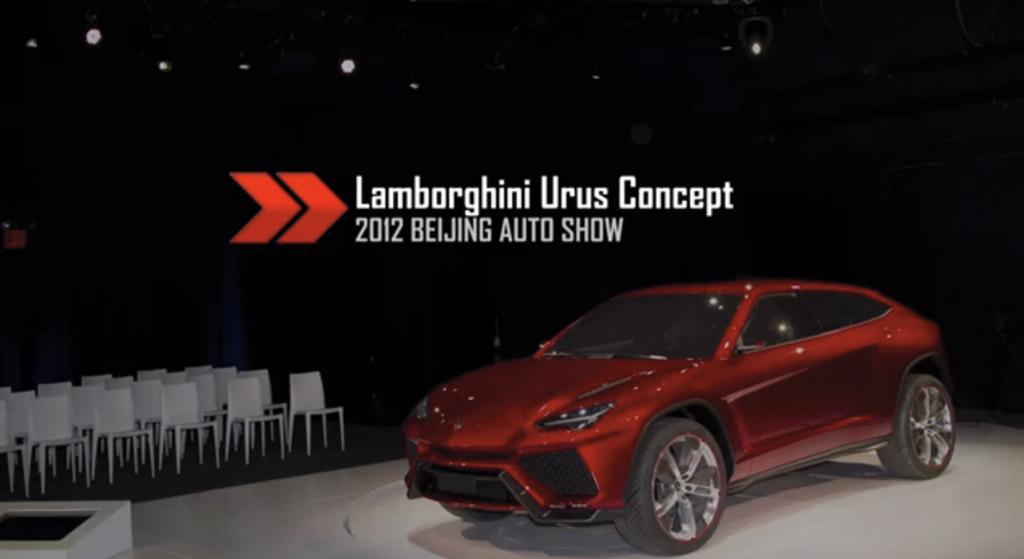Could you give a brief overview of what you see in this image? In this picture we can see a red color car in the front, on the left side there are chairs, we can see some text in the middle, there is a dark background, we can also see some lights. 